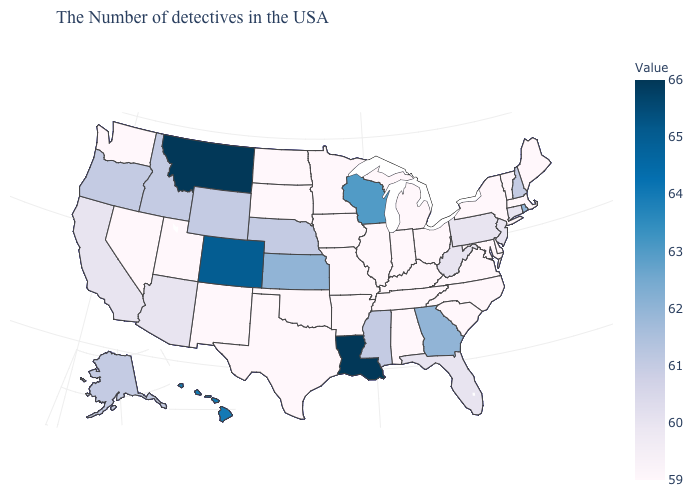Among the states that border Florida , does Georgia have the lowest value?
Keep it brief. No. Which states have the lowest value in the South?
Keep it brief. Delaware, Maryland, Virginia, North Carolina, South Carolina, Kentucky, Alabama, Tennessee, Arkansas, Oklahoma, Texas. Among the states that border Louisiana , does Texas have the lowest value?
Short answer required. Yes. Does Idaho have the lowest value in the West?
Short answer required. No. Which states have the highest value in the USA?
Write a very short answer. Louisiana, Montana. 